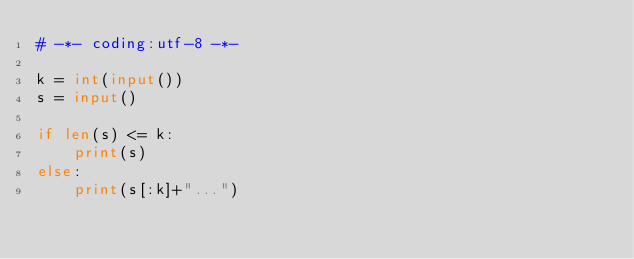<code> <loc_0><loc_0><loc_500><loc_500><_Python_># -*- coding:utf-8 -*-

k = int(input())
s = input()

if len(s) <= k:
    print(s)
else:
    print(s[:k]+"...")
</code> 